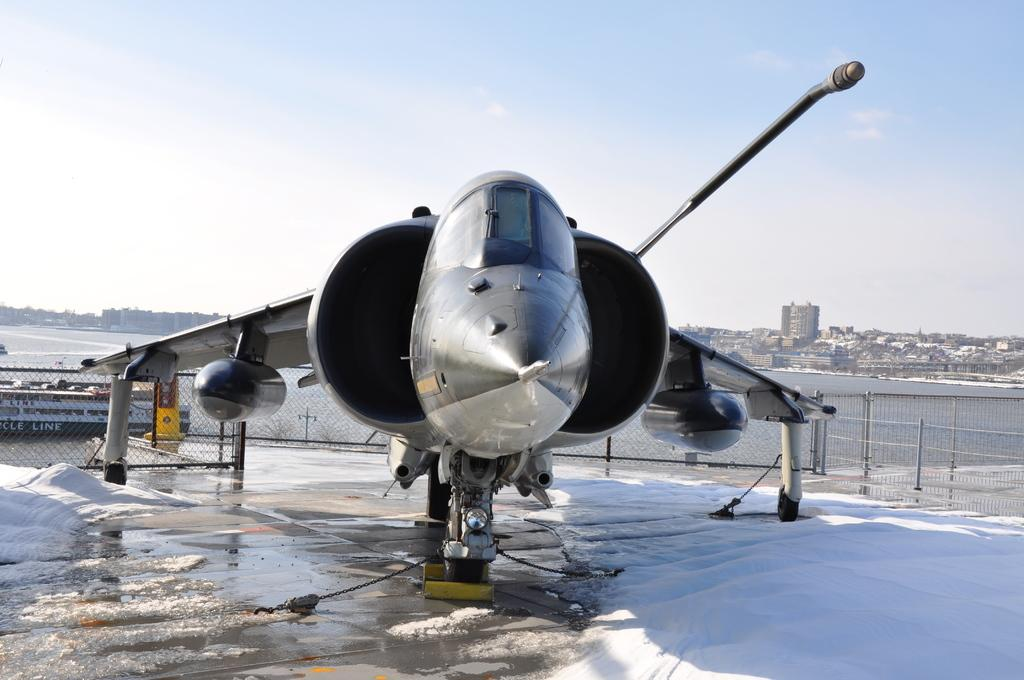What is the main subject of the image? The main subject of the image is an aeroplane. Can you describe the color of the aeroplane? The aeroplane is in black and grey color. What type of weather is depicted in the image? There is snow in the image, indicating a cold or wintry weather. What else can be seen in the image besides the aeroplane? There is fencing, water, buildings, and a blue and white sky in the image. What type of glass is being used to cover the aeroplane in the image? There is no glass covering the aeroplane in the image; it is flying in the sky. Can you hear a whistle in the image? There is no sound or indication of a whistle in the image. 